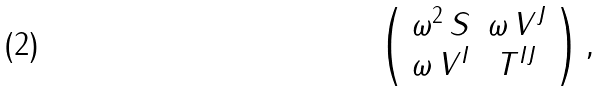<formula> <loc_0><loc_0><loc_500><loc_500>\left ( \begin{array} { c c } \omega ^ { 2 } \, S & \omega \, V ^ { J } \\ \omega \, V ^ { I } & T ^ { I J } \end{array} \right ) ,</formula> 